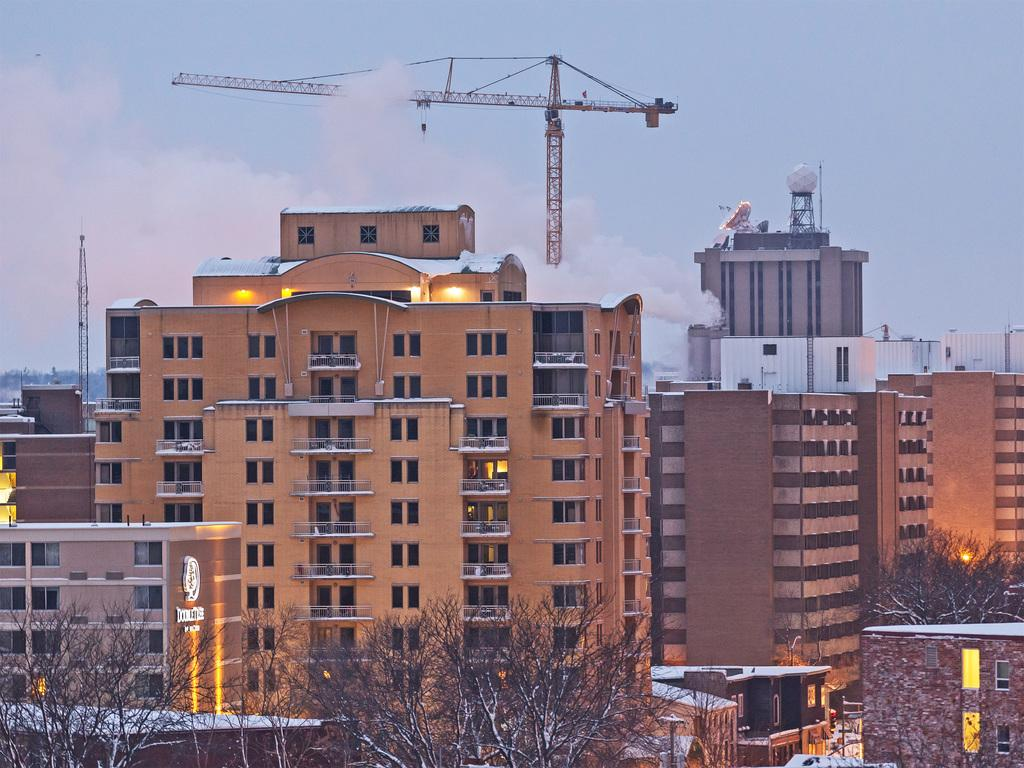What type of structures can be seen in the image? There are tall buildings and houses in the image. What is located in the front of the image? There are trees in the front of the image. What color is the sky in the background of the image? The sky is blue in the background of the image. What piece of construction equipment can be seen in the background of the image? There is a crane visible in the background of the image. What type of lipstick is being advertised on the tall buildings in the image? There is no lipstick or advertisement present on the tall buildings in the image. 